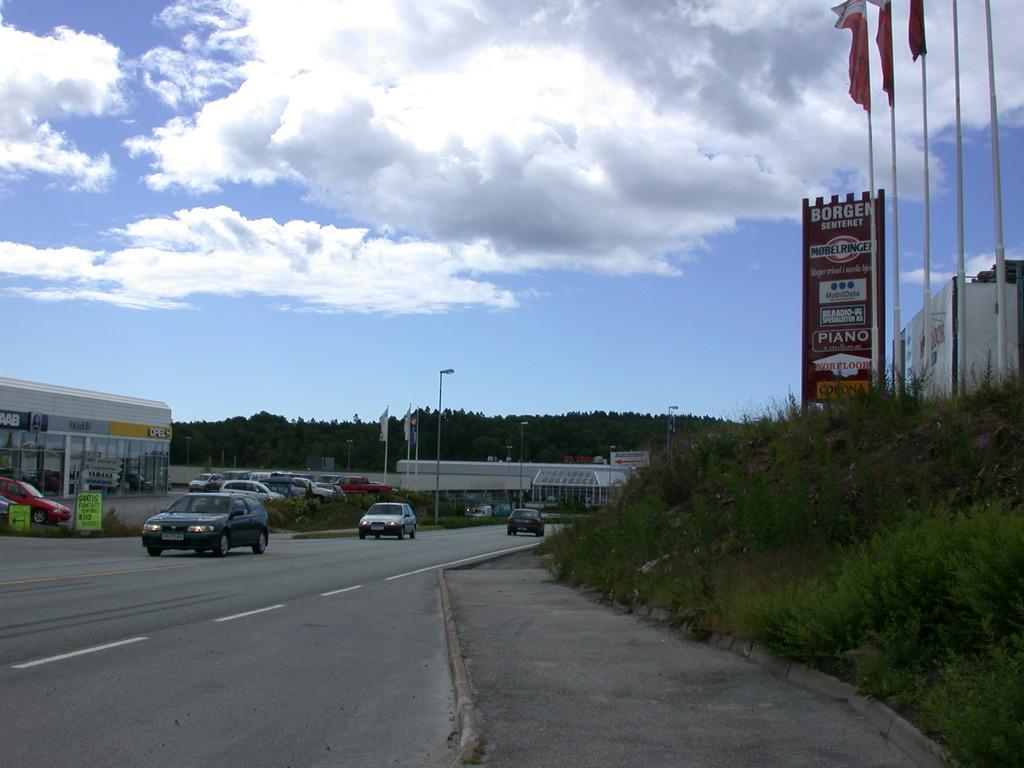What types of objects can be seen in the image? There are plants, poles, boards, flags, vehicles, buildings, trees, and a road visible in the image. What else can be seen in the image besides these objects? The sky is visible in the background of the image, with clouds present. What type of foot can be seen on the plants in the image? There are no feet present in the image, as it features plants, poles, boards, flags, vehicles, buildings, trees, a road, and a sky with clouds. 